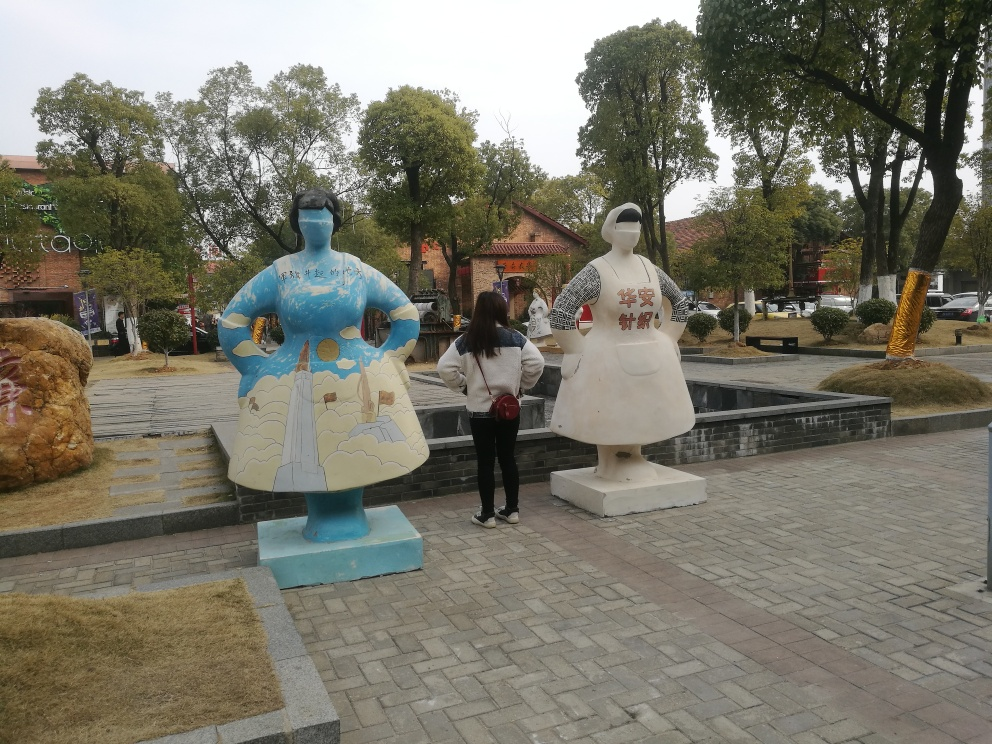What's the artistic significance of the statues in the center of the image? The statues appear to be artistically significant, suggesting a cultural or local theme. They are stylized representations of human figures, painted with designs that could be indicative of regional art, historical references, or perhaps public art installations meant to celebrate certain aspects of local heritage or contemporary creativity. How do these statues contribute to the ambience of this place? These statues add a distinctive character to the location. As objects of public art, they not only decorate the space but also foster a sense of community identity. They might be a point of interest for locals and tourists alike, encouraging people to pause, engage with the art, and possibly act as photo opportunities that capture the uniqueness of this area. 